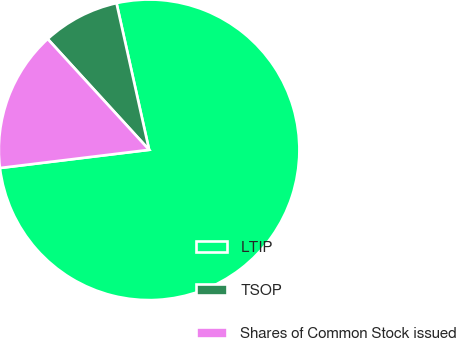<chart> <loc_0><loc_0><loc_500><loc_500><pie_chart><fcel>LTIP<fcel>TSOP<fcel>Shares of Common Stock issued<nl><fcel>76.55%<fcel>8.31%<fcel>15.14%<nl></chart> 